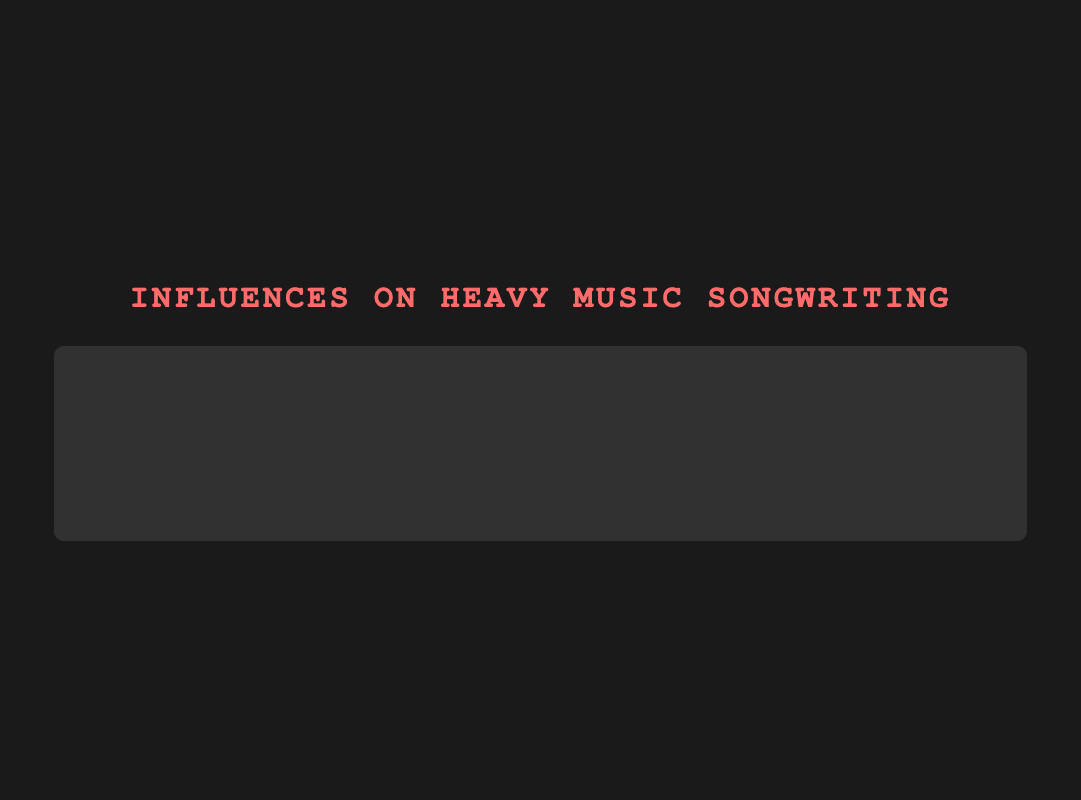What musical style shows the greatest influence on guitarists? Look at the bar with the maximum height for guitarists. The "Metal" bar for guitarists is the tallest with a score of 100.
Answer: Metal Between guitarists and bassists, who has the higher influence score for Jazz? Compare the heights of the Jazz bars for both guitarists and bassists. The bassist (Jaco Pastorius) has a higher score of 90, compared to the guitarist (Wes Montgomery) who has a score of 60.
Answer: Bassist Which musical styles have a higher influence score for bassists compared to guitarists? Check each musical style where the bassist's bar is taller than the guitarist's bar. These are Jazz, Funk, and Country.
Answer: Jazz, Funk, Country What is the average influence score for guitarists across all musical styles? Sum all the influence scores for guitarists and divide by the number of musical styles. The scores are 85, 60, 75, 95, 100, 80, 55, and 65. The sum is 615, and there are 8 styles. The average is 615/8 = 76.875.
Answer: 76.875 How much greater is the influence score of Jimi Hendrix (Rock) compared to Prince (Funk) for guitarists? Subtract Prince's influence score from Jimi Hendrix's influence score. Jimi Hendrix has 95, and Prince has 55. The difference is 95 - 55 = 40.
Answer: 40 Which musical style has a nearly equal influence on both guitarists and bassists? Identify the musical style with bars for guitarists and bassists of almost the same length. This style is Progressive, where both scores are 80 (Guitarist: Robert Fripp) and 85 (Bassist: Geddy Lee).
Answer: Progressive What is the sum of influence scores for bassists in Classical and Rock styles? Add the influence scores of bassists in Classical (Edgar Meyer: 65) and Rock (John Entwistle: 85). The sum is 65 + 85 = 150.
Answer: 150 For which musical style is the influence score difference between guitarists and bassists highest? Find the absolute difference between influence scores for each style and identify the maximum. Differences: Blues (15), Jazz (30), Classical (10), Rock (10), Metal (10), Progressive (5), Funk (35), Country (15). The highest is Funk (35).
Answer: Funk In the style of Blues, who is more influential, and by how much? Compare the influence scores for Blues. Stevie Ray Vaughan (Guitarist: 85) vs. Jack Bruce (Bassist: 70). The guitarist is more influential by 85 - 70 = 15.
Answer: Guitarist by 15 Which musician has the highest influence score among all listed? Identify the musician with the highest score across all styles. Tony Iommi (Guitarist: Metal) has the top score of 100.
Answer: Tony Iommi 